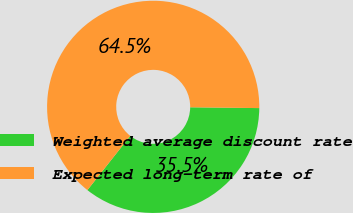<chart> <loc_0><loc_0><loc_500><loc_500><pie_chart><fcel>Weighted average discount rate<fcel>Expected long-term rate of<nl><fcel>35.46%<fcel>64.54%<nl></chart> 